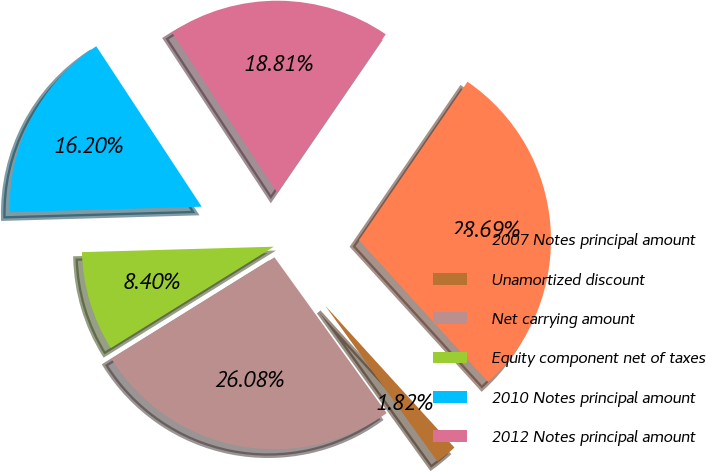Convert chart. <chart><loc_0><loc_0><loc_500><loc_500><pie_chart><fcel>2007 Notes principal amount<fcel>Unamortized discount<fcel>Net carrying amount<fcel>Equity component net of taxes<fcel>2010 Notes principal amount<fcel>2012 Notes principal amount<nl><fcel>28.69%<fcel>1.82%<fcel>26.08%<fcel>8.4%<fcel>16.2%<fcel>18.81%<nl></chart> 